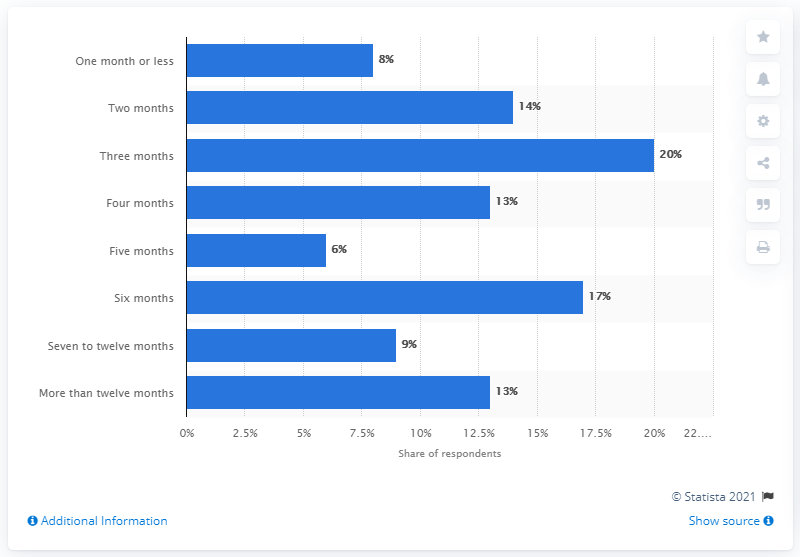Outline some significant characteristics in this image. According to a survey, a significant percentage of people believe that four months is the appropriate amount of time to work on a project. The two options provided, "Four months" and "More than twelve months," have a 1:1 ratio. 